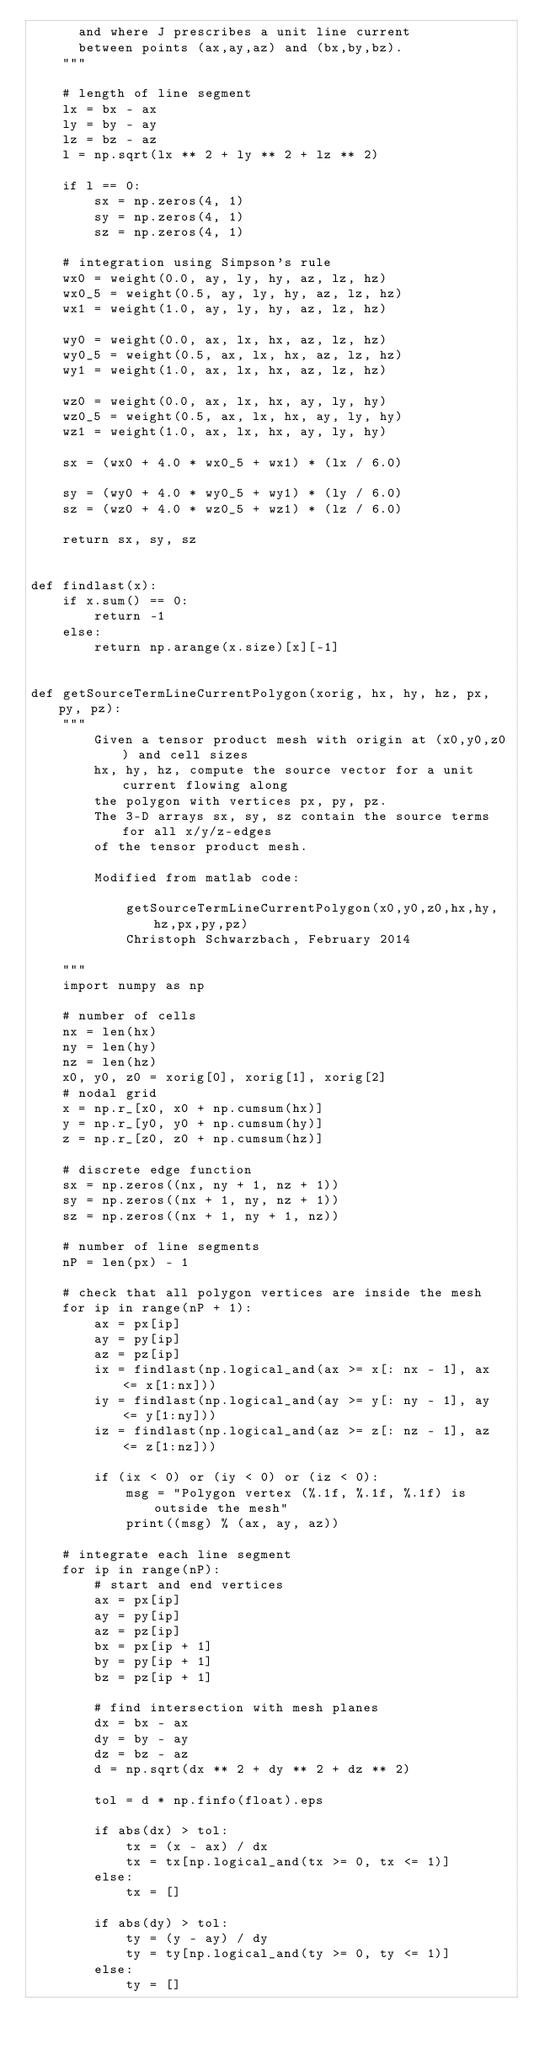<code> <loc_0><loc_0><loc_500><loc_500><_Python_>      and where J prescribes a unit line current
      between points (ax,ay,az) and (bx,by,bz).
    """

    # length of line segment
    lx = bx - ax
    ly = by - ay
    lz = bz - az
    l = np.sqrt(lx ** 2 + ly ** 2 + lz ** 2)

    if l == 0:
        sx = np.zeros(4, 1)
        sy = np.zeros(4, 1)
        sz = np.zeros(4, 1)

    # integration using Simpson's rule
    wx0 = weight(0.0, ay, ly, hy, az, lz, hz)
    wx0_5 = weight(0.5, ay, ly, hy, az, lz, hz)
    wx1 = weight(1.0, ay, ly, hy, az, lz, hz)

    wy0 = weight(0.0, ax, lx, hx, az, lz, hz)
    wy0_5 = weight(0.5, ax, lx, hx, az, lz, hz)
    wy1 = weight(1.0, ax, lx, hx, az, lz, hz)

    wz0 = weight(0.0, ax, lx, hx, ay, ly, hy)
    wz0_5 = weight(0.5, ax, lx, hx, ay, ly, hy)
    wz1 = weight(1.0, ax, lx, hx, ay, ly, hy)

    sx = (wx0 + 4.0 * wx0_5 + wx1) * (lx / 6.0)

    sy = (wy0 + 4.0 * wy0_5 + wy1) * (ly / 6.0)
    sz = (wz0 + 4.0 * wz0_5 + wz1) * (lz / 6.0)

    return sx, sy, sz


def findlast(x):
    if x.sum() == 0:
        return -1
    else:
        return np.arange(x.size)[x][-1]


def getSourceTermLineCurrentPolygon(xorig, hx, hy, hz, px, py, pz):
    """
        Given a tensor product mesh with origin at (x0,y0,z0) and cell sizes
        hx, hy, hz, compute the source vector for a unit current flowing along
        the polygon with vertices px, py, pz.
        The 3-D arrays sx, sy, sz contain the source terms for all x/y/z-edges
        of the tensor product mesh.

        Modified from matlab code:

            getSourceTermLineCurrentPolygon(x0,y0,z0,hx,hy,hz,px,py,pz)
            Christoph Schwarzbach, February 2014

    """
    import numpy as np

    # number of cells
    nx = len(hx)
    ny = len(hy)
    nz = len(hz)
    x0, y0, z0 = xorig[0], xorig[1], xorig[2]
    # nodal grid
    x = np.r_[x0, x0 + np.cumsum(hx)]
    y = np.r_[y0, y0 + np.cumsum(hy)]
    z = np.r_[z0, z0 + np.cumsum(hz)]

    # discrete edge function
    sx = np.zeros((nx, ny + 1, nz + 1))
    sy = np.zeros((nx + 1, ny, nz + 1))
    sz = np.zeros((nx + 1, ny + 1, nz))

    # number of line segments
    nP = len(px) - 1

    # check that all polygon vertices are inside the mesh
    for ip in range(nP + 1):
        ax = px[ip]
        ay = py[ip]
        az = pz[ip]
        ix = findlast(np.logical_and(ax >= x[: nx - 1], ax <= x[1:nx]))
        iy = findlast(np.logical_and(ay >= y[: ny - 1], ay <= y[1:ny]))
        iz = findlast(np.logical_and(az >= z[: nz - 1], az <= z[1:nz]))

        if (ix < 0) or (iy < 0) or (iz < 0):
            msg = "Polygon vertex (%.1f, %.1f, %.1f) is outside the mesh"
            print((msg) % (ax, ay, az))

    # integrate each line segment
    for ip in range(nP):
        # start and end vertices
        ax = px[ip]
        ay = py[ip]
        az = pz[ip]
        bx = px[ip + 1]
        by = py[ip + 1]
        bz = pz[ip + 1]

        # find intersection with mesh planes
        dx = bx - ax
        dy = by - ay
        dz = bz - az
        d = np.sqrt(dx ** 2 + dy ** 2 + dz ** 2)

        tol = d * np.finfo(float).eps

        if abs(dx) > tol:
            tx = (x - ax) / dx
            tx = tx[np.logical_and(tx >= 0, tx <= 1)]
        else:
            tx = []

        if abs(dy) > tol:
            ty = (y - ay) / dy
            ty = ty[np.logical_and(ty >= 0, ty <= 1)]
        else:
            ty = []
</code> 